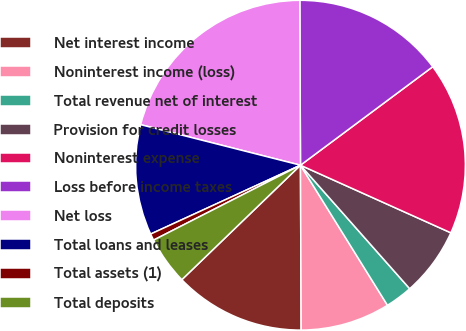Convert chart to OTSL. <chart><loc_0><loc_0><loc_500><loc_500><pie_chart><fcel>Net interest income<fcel>Noninterest income (loss)<fcel>Total revenue net of interest<fcel>Provision for credit losses<fcel>Noninterest expense<fcel>Loss before income taxes<fcel>Net loss<fcel>Total loans and leases<fcel>Total assets (1)<fcel>Total deposits<nl><fcel>12.85%<fcel>8.78%<fcel>2.68%<fcel>6.75%<fcel>16.91%<fcel>14.88%<fcel>20.98%<fcel>10.81%<fcel>0.65%<fcel>4.71%<nl></chart> 